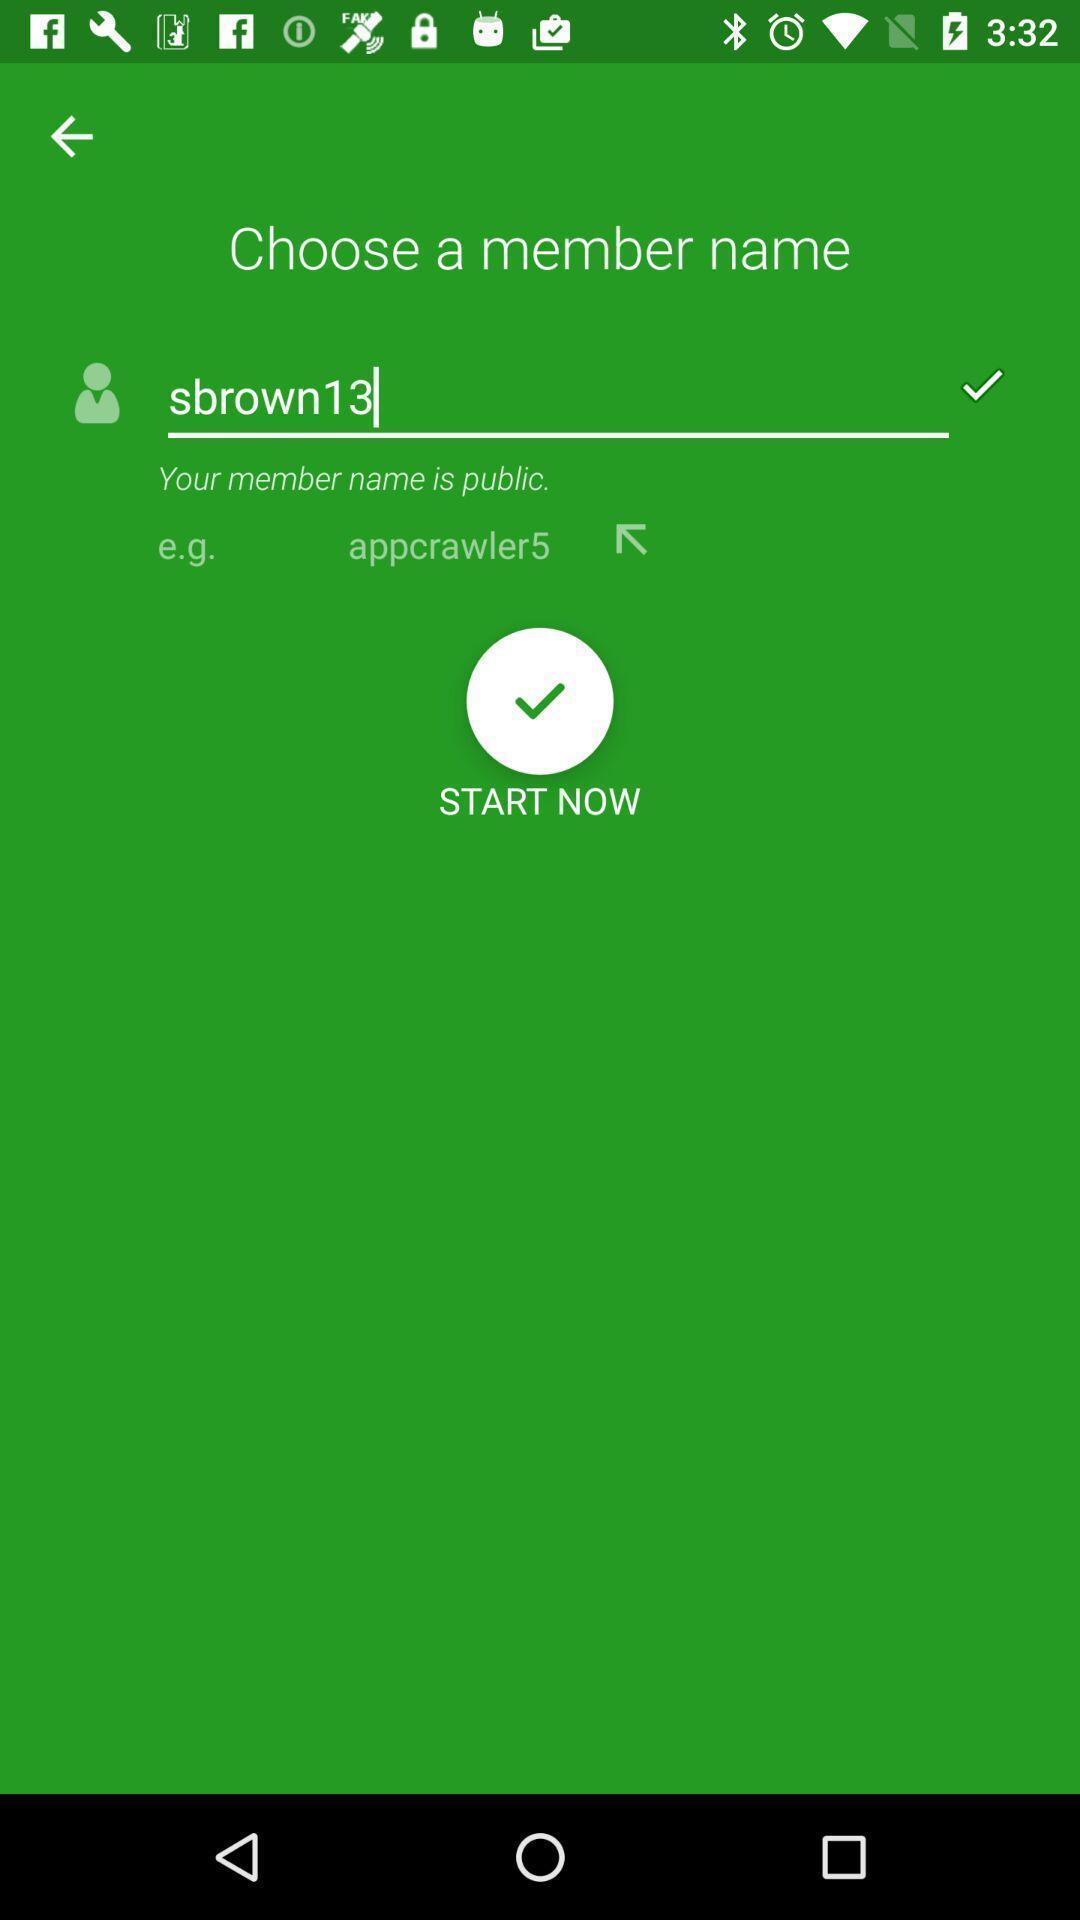Explain the elements present in this screenshot. Starting page. 